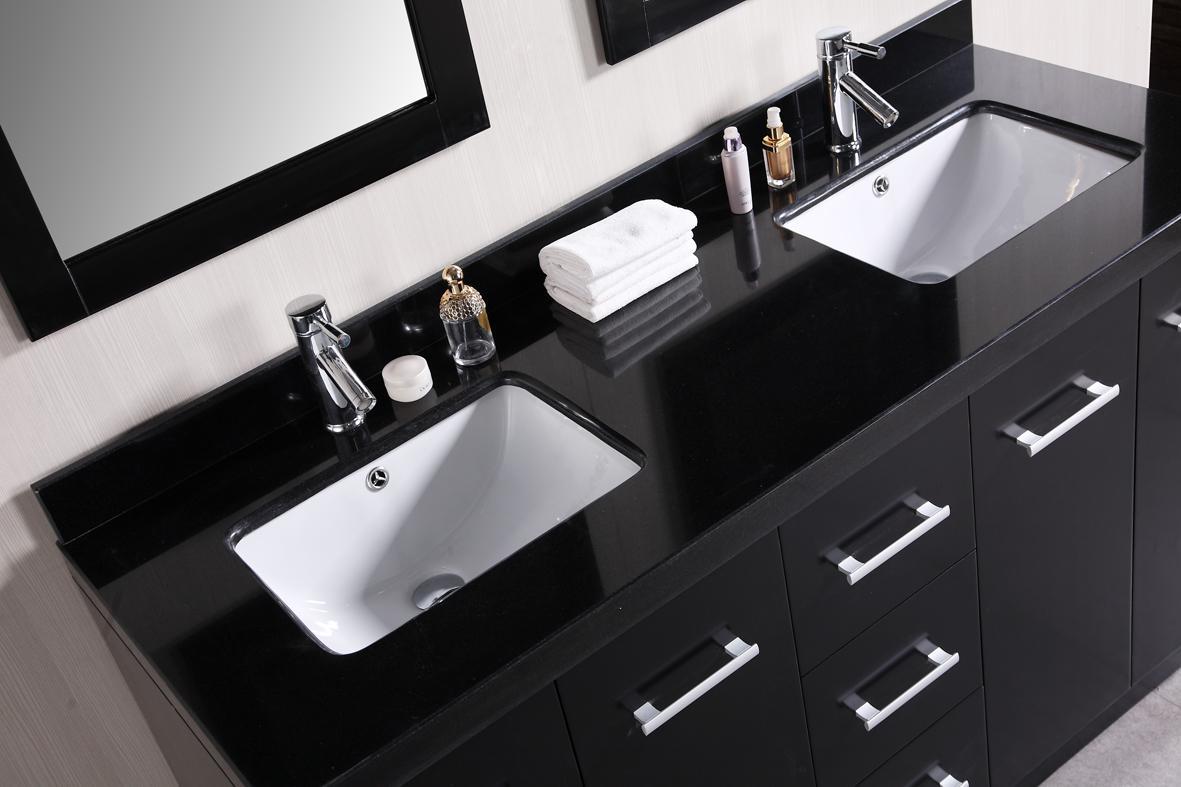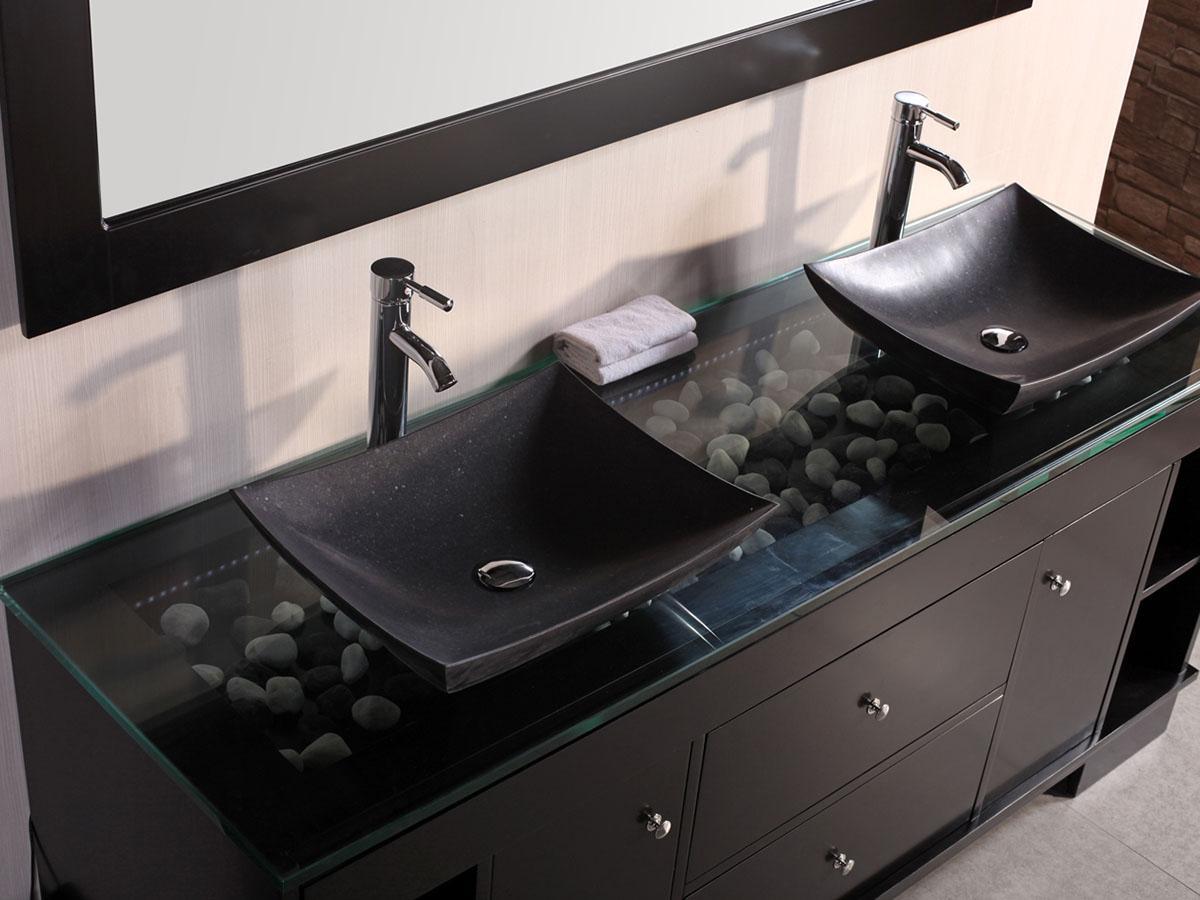The first image is the image on the left, the second image is the image on the right. Analyze the images presented: Is the assertion "An image shows a top-view of a black-and-white sink and vanity combination, with two rectangular sinks inset in the counter, and a mirror above each sink." valid? Answer yes or no. Yes. The first image is the image on the left, the second image is the image on the right. Examine the images to the left and right. Is the description "The counter in the image on the left is black and has two white sinks." accurate? Answer yes or no. Yes. 